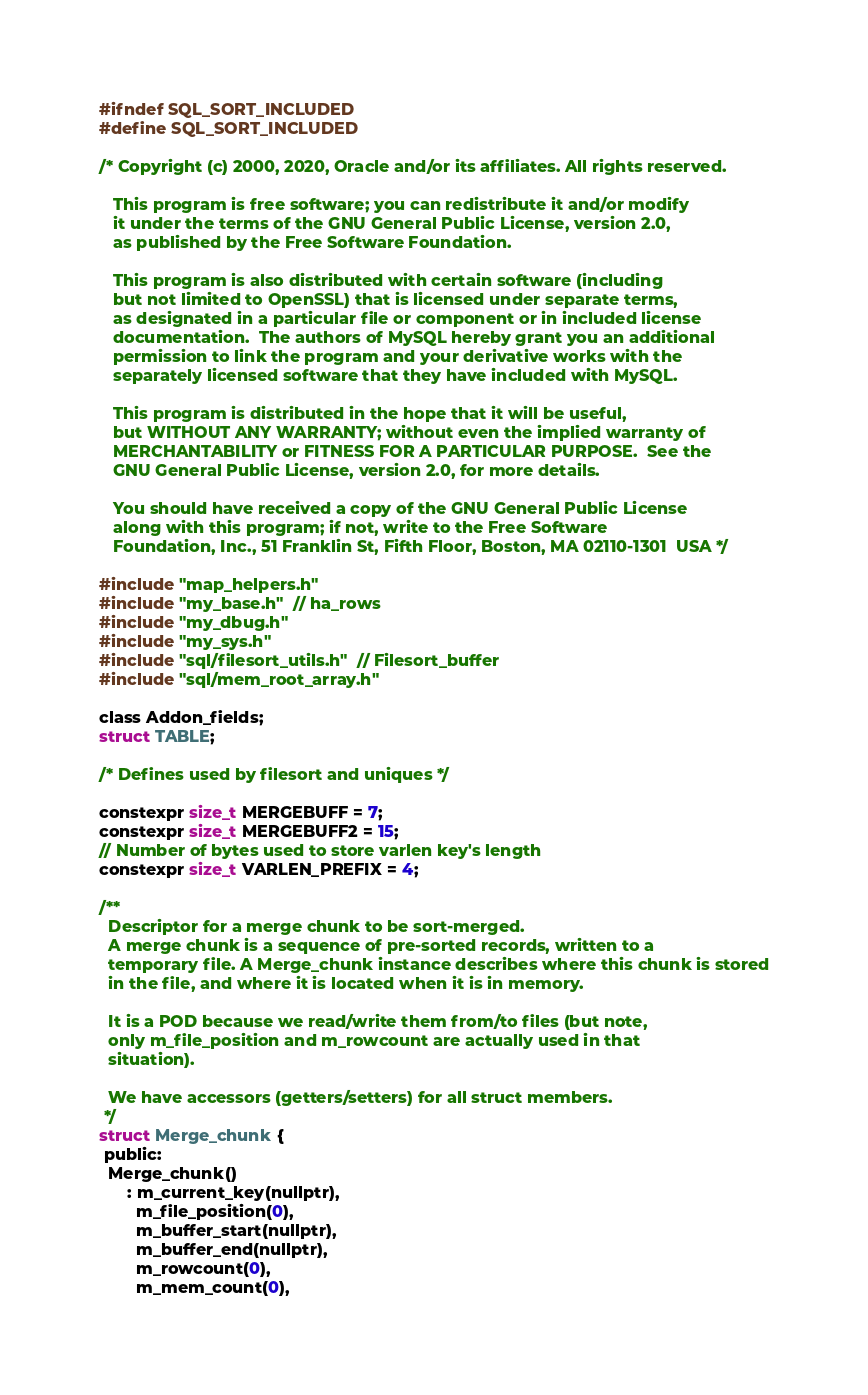Convert code to text. <code><loc_0><loc_0><loc_500><loc_500><_C_>#ifndef SQL_SORT_INCLUDED
#define SQL_SORT_INCLUDED

/* Copyright (c) 2000, 2020, Oracle and/or its affiliates. All rights reserved.

   This program is free software; you can redistribute it and/or modify
   it under the terms of the GNU General Public License, version 2.0,
   as published by the Free Software Foundation.

   This program is also distributed with certain software (including
   but not limited to OpenSSL) that is licensed under separate terms,
   as designated in a particular file or component or in included license
   documentation.  The authors of MySQL hereby grant you an additional
   permission to link the program and your derivative works with the
   separately licensed software that they have included with MySQL.

   This program is distributed in the hope that it will be useful,
   but WITHOUT ANY WARRANTY; without even the implied warranty of
   MERCHANTABILITY or FITNESS FOR A PARTICULAR PURPOSE.  See the
   GNU General Public License, version 2.0, for more details.

   You should have received a copy of the GNU General Public License
   along with this program; if not, write to the Free Software
   Foundation, Inc., 51 Franklin St, Fifth Floor, Boston, MA 02110-1301  USA */

#include "map_helpers.h"
#include "my_base.h"  // ha_rows
#include "my_dbug.h"
#include "my_sys.h"
#include "sql/filesort_utils.h"  // Filesort_buffer
#include "sql/mem_root_array.h"

class Addon_fields;
struct TABLE;

/* Defines used by filesort and uniques */

constexpr size_t MERGEBUFF = 7;
constexpr size_t MERGEBUFF2 = 15;
// Number of bytes used to store varlen key's length
constexpr size_t VARLEN_PREFIX = 4;

/**
  Descriptor for a merge chunk to be sort-merged.
  A merge chunk is a sequence of pre-sorted records, written to a
  temporary file. A Merge_chunk instance describes where this chunk is stored
  in the file, and where it is located when it is in memory.

  It is a POD because we read/write them from/to files (but note,
  only m_file_position and m_rowcount are actually used in that
  situation).

  We have accessors (getters/setters) for all struct members.
 */
struct Merge_chunk {
 public:
  Merge_chunk()
      : m_current_key(nullptr),
        m_file_position(0),
        m_buffer_start(nullptr),
        m_buffer_end(nullptr),
        m_rowcount(0),
        m_mem_count(0),</code> 